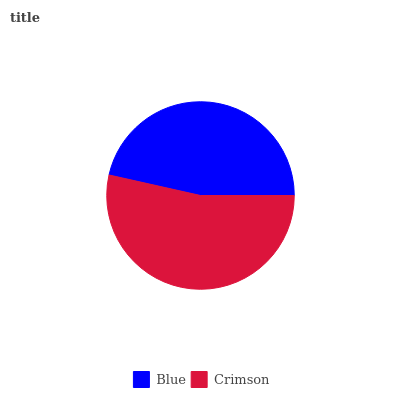Is Blue the minimum?
Answer yes or no. Yes. Is Crimson the maximum?
Answer yes or no. Yes. Is Crimson the minimum?
Answer yes or no. No. Is Crimson greater than Blue?
Answer yes or no. Yes. Is Blue less than Crimson?
Answer yes or no. Yes. Is Blue greater than Crimson?
Answer yes or no. No. Is Crimson less than Blue?
Answer yes or no. No. Is Crimson the high median?
Answer yes or no. Yes. Is Blue the low median?
Answer yes or no. Yes. Is Blue the high median?
Answer yes or no. No. Is Crimson the low median?
Answer yes or no. No. 